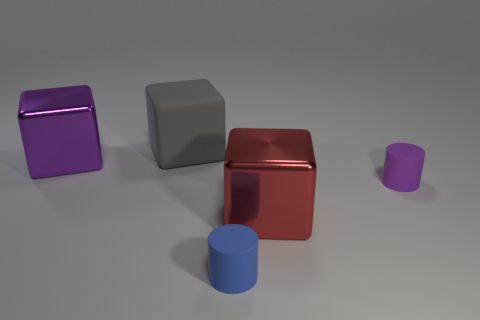Add 2 large gray cylinders. How many objects exist? 7 Subtract all cubes. How many objects are left? 2 Subtract 0 red balls. How many objects are left? 5 Subtract all purple objects. Subtract all large gray matte cubes. How many objects are left? 2 Add 1 purple cylinders. How many purple cylinders are left? 2 Add 1 big red metallic cylinders. How many big red metallic cylinders exist? 1 